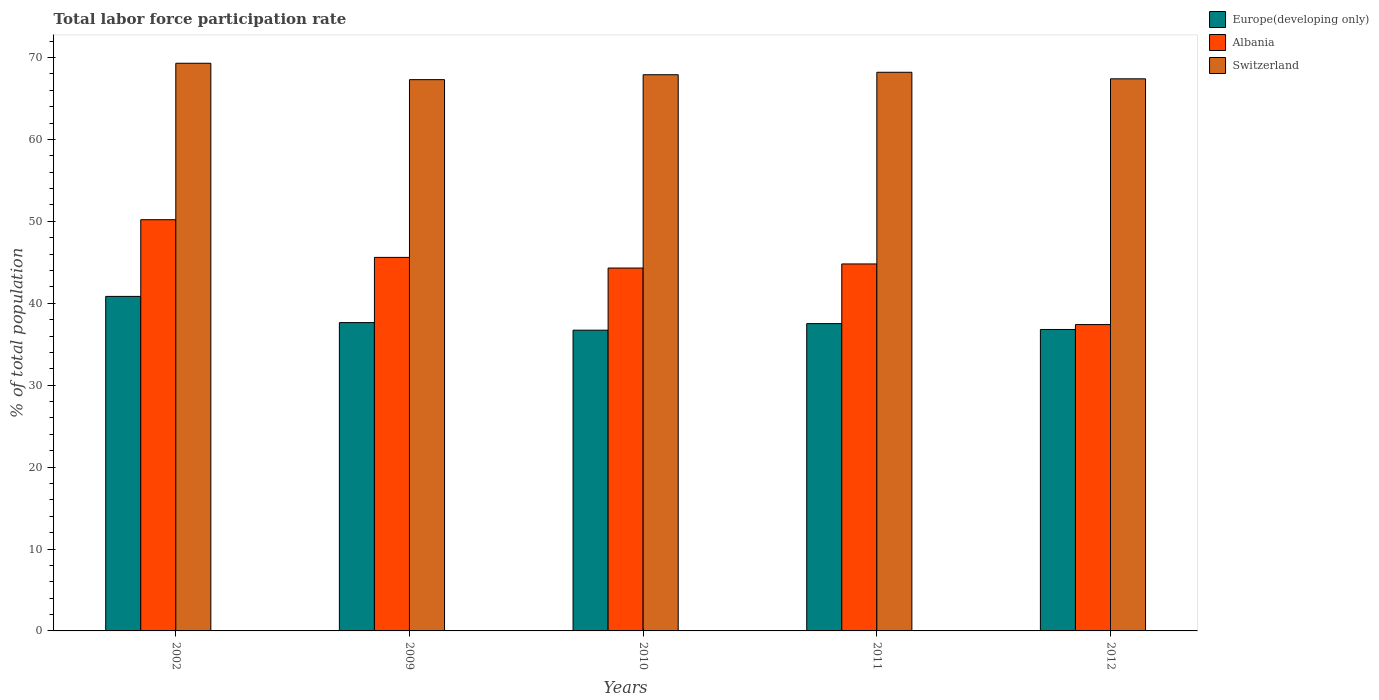Are the number of bars on each tick of the X-axis equal?
Make the answer very short. Yes. How many bars are there on the 4th tick from the left?
Your response must be concise. 3. How many bars are there on the 3rd tick from the right?
Your response must be concise. 3. In how many cases, is the number of bars for a given year not equal to the number of legend labels?
Ensure brevity in your answer.  0. What is the total labor force participation rate in Albania in 2012?
Make the answer very short. 37.4. Across all years, what is the maximum total labor force participation rate in Europe(developing only)?
Offer a terse response. 40.84. Across all years, what is the minimum total labor force participation rate in Albania?
Your response must be concise. 37.4. What is the total total labor force participation rate in Albania in the graph?
Offer a terse response. 222.3. What is the difference between the total labor force participation rate in Switzerland in 2002 and that in 2011?
Offer a very short reply. 1.1. What is the difference between the total labor force participation rate in Europe(developing only) in 2009 and the total labor force participation rate in Albania in 2012?
Keep it short and to the point. 0.24. What is the average total labor force participation rate in Albania per year?
Provide a succinct answer. 44.46. In the year 2010, what is the difference between the total labor force participation rate in Europe(developing only) and total labor force participation rate in Switzerland?
Provide a short and direct response. -31.19. What is the ratio of the total labor force participation rate in Europe(developing only) in 2002 to that in 2010?
Your answer should be compact. 1.11. What is the difference between the highest and the second highest total labor force participation rate in Switzerland?
Provide a succinct answer. 1.1. What is the difference between the highest and the lowest total labor force participation rate in Albania?
Offer a terse response. 12.8. In how many years, is the total labor force participation rate in Albania greater than the average total labor force participation rate in Albania taken over all years?
Give a very brief answer. 3. Is the sum of the total labor force participation rate in Switzerland in 2010 and 2012 greater than the maximum total labor force participation rate in Europe(developing only) across all years?
Offer a terse response. Yes. What does the 3rd bar from the left in 2009 represents?
Ensure brevity in your answer.  Switzerland. What does the 2nd bar from the right in 2009 represents?
Make the answer very short. Albania. Are all the bars in the graph horizontal?
Your response must be concise. No. How many years are there in the graph?
Your answer should be very brief. 5. What is the difference between two consecutive major ticks on the Y-axis?
Give a very brief answer. 10. Are the values on the major ticks of Y-axis written in scientific E-notation?
Provide a succinct answer. No. Does the graph contain any zero values?
Give a very brief answer. No. Where does the legend appear in the graph?
Offer a very short reply. Top right. How many legend labels are there?
Your answer should be compact. 3. What is the title of the graph?
Provide a short and direct response. Total labor force participation rate. Does "Korea (Republic)" appear as one of the legend labels in the graph?
Your response must be concise. No. What is the label or title of the Y-axis?
Offer a terse response. % of total population. What is the % of total population in Europe(developing only) in 2002?
Your answer should be very brief. 40.84. What is the % of total population of Albania in 2002?
Offer a terse response. 50.2. What is the % of total population in Switzerland in 2002?
Give a very brief answer. 69.3. What is the % of total population in Europe(developing only) in 2009?
Provide a short and direct response. 37.64. What is the % of total population of Albania in 2009?
Make the answer very short. 45.6. What is the % of total population in Switzerland in 2009?
Give a very brief answer. 67.3. What is the % of total population of Europe(developing only) in 2010?
Give a very brief answer. 36.71. What is the % of total population of Albania in 2010?
Make the answer very short. 44.3. What is the % of total population in Switzerland in 2010?
Offer a terse response. 67.9. What is the % of total population in Europe(developing only) in 2011?
Your answer should be very brief. 37.52. What is the % of total population of Albania in 2011?
Provide a succinct answer. 44.8. What is the % of total population of Switzerland in 2011?
Offer a terse response. 68.2. What is the % of total population of Europe(developing only) in 2012?
Give a very brief answer. 36.8. What is the % of total population in Albania in 2012?
Offer a very short reply. 37.4. What is the % of total population in Switzerland in 2012?
Offer a very short reply. 67.4. Across all years, what is the maximum % of total population of Europe(developing only)?
Provide a succinct answer. 40.84. Across all years, what is the maximum % of total population in Albania?
Your answer should be very brief. 50.2. Across all years, what is the maximum % of total population of Switzerland?
Your answer should be very brief. 69.3. Across all years, what is the minimum % of total population in Europe(developing only)?
Offer a terse response. 36.71. Across all years, what is the minimum % of total population in Albania?
Your answer should be compact. 37.4. Across all years, what is the minimum % of total population in Switzerland?
Provide a succinct answer. 67.3. What is the total % of total population in Europe(developing only) in the graph?
Your answer should be very brief. 189.51. What is the total % of total population in Albania in the graph?
Offer a terse response. 222.3. What is the total % of total population of Switzerland in the graph?
Offer a terse response. 340.1. What is the difference between the % of total population in Europe(developing only) in 2002 and that in 2009?
Keep it short and to the point. 3.2. What is the difference between the % of total population of Albania in 2002 and that in 2009?
Your answer should be compact. 4.6. What is the difference between the % of total population in Switzerland in 2002 and that in 2009?
Give a very brief answer. 2. What is the difference between the % of total population in Europe(developing only) in 2002 and that in 2010?
Keep it short and to the point. 4.12. What is the difference between the % of total population of Europe(developing only) in 2002 and that in 2011?
Make the answer very short. 3.32. What is the difference between the % of total population in Albania in 2002 and that in 2011?
Your answer should be compact. 5.4. What is the difference between the % of total population in Europe(developing only) in 2002 and that in 2012?
Your answer should be very brief. 4.04. What is the difference between the % of total population of Albania in 2002 and that in 2012?
Your answer should be compact. 12.8. What is the difference between the % of total population in Switzerland in 2002 and that in 2012?
Make the answer very short. 1.9. What is the difference between the % of total population of Europe(developing only) in 2009 and that in 2010?
Give a very brief answer. 0.92. What is the difference between the % of total population of Albania in 2009 and that in 2010?
Your answer should be compact. 1.3. What is the difference between the % of total population in Switzerland in 2009 and that in 2010?
Your answer should be compact. -0.6. What is the difference between the % of total population in Europe(developing only) in 2009 and that in 2011?
Your answer should be very brief. 0.12. What is the difference between the % of total population of Albania in 2009 and that in 2011?
Your response must be concise. 0.8. What is the difference between the % of total population in Europe(developing only) in 2009 and that in 2012?
Make the answer very short. 0.84. What is the difference between the % of total population in Albania in 2009 and that in 2012?
Your answer should be very brief. 8.2. What is the difference between the % of total population of Europe(developing only) in 2010 and that in 2011?
Your response must be concise. -0.8. What is the difference between the % of total population in Albania in 2010 and that in 2011?
Your response must be concise. -0.5. What is the difference between the % of total population of Switzerland in 2010 and that in 2011?
Ensure brevity in your answer.  -0.3. What is the difference between the % of total population of Europe(developing only) in 2010 and that in 2012?
Provide a succinct answer. -0.09. What is the difference between the % of total population of Switzerland in 2010 and that in 2012?
Give a very brief answer. 0.5. What is the difference between the % of total population in Europe(developing only) in 2011 and that in 2012?
Your response must be concise. 0.72. What is the difference between the % of total population in Switzerland in 2011 and that in 2012?
Your response must be concise. 0.8. What is the difference between the % of total population of Europe(developing only) in 2002 and the % of total population of Albania in 2009?
Your response must be concise. -4.76. What is the difference between the % of total population in Europe(developing only) in 2002 and the % of total population in Switzerland in 2009?
Keep it short and to the point. -26.46. What is the difference between the % of total population in Albania in 2002 and the % of total population in Switzerland in 2009?
Your response must be concise. -17.1. What is the difference between the % of total population of Europe(developing only) in 2002 and the % of total population of Albania in 2010?
Ensure brevity in your answer.  -3.46. What is the difference between the % of total population of Europe(developing only) in 2002 and the % of total population of Switzerland in 2010?
Give a very brief answer. -27.06. What is the difference between the % of total population in Albania in 2002 and the % of total population in Switzerland in 2010?
Keep it short and to the point. -17.7. What is the difference between the % of total population in Europe(developing only) in 2002 and the % of total population in Albania in 2011?
Offer a very short reply. -3.96. What is the difference between the % of total population in Europe(developing only) in 2002 and the % of total population in Switzerland in 2011?
Make the answer very short. -27.36. What is the difference between the % of total population of Albania in 2002 and the % of total population of Switzerland in 2011?
Offer a very short reply. -18. What is the difference between the % of total population of Europe(developing only) in 2002 and the % of total population of Albania in 2012?
Ensure brevity in your answer.  3.44. What is the difference between the % of total population in Europe(developing only) in 2002 and the % of total population in Switzerland in 2012?
Offer a terse response. -26.56. What is the difference between the % of total population in Albania in 2002 and the % of total population in Switzerland in 2012?
Provide a short and direct response. -17.2. What is the difference between the % of total population of Europe(developing only) in 2009 and the % of total population of Albania in 2010?
Your answer should be very brief. -6.66. What is the difference between the % of total population of Europe(developing only) in 2009 and the % of total population of Switzerland in 2010?
Keep it short and to the point. -30.26. What is the difference between the % of total population in Albania in 2009 and the % of total population in Switzerland in 2010?
Offer a terse response. -22.3. What is the difference between the % of total population of Europe(developing only) in 2009 and the % of total population of Albania in 2011?
Your response must be concise. -7.16. What is the difference between the % of total population of Europe(developing only) in 2009 and the % of total population of Switzerland in 2011?
Your response must be concise. -30.56. What is the difference between the % of total population in Albania in 2009 and the % of total population in Switzerland in 2011?
Your answer should be compact. -22.6. What is the difference between the % of total population of Europe(developing only) in 2009 and the % of total population of Albania in 2012?
Offer a very short reply. 0.24. What is the difference between the % of total population of Europe(developing only) in 2009 and the % of total population of Switzerland in 2012?
Your answer should be very brief. -29.76. What is the difference between the % of total population of Albania in 2009 and the % of total population of Switzerland in 2012?
Provide a succinct answer. -21.8. What is the difference between the % of total population in Europe(developing only) in 2010 and the % of total population in Albania in 2011?
Keep it short and to the point. -8.09. What is the difference between the % of total population in Europe(developing only) in 2010 and the % of total population in Switzerland in 2011?
Your response must be concise. -31.49. What is the difference between the % of total population of Albania in 2010 and the % of total population of Switzerland in 2011?
Provide a short and direct response. -23.9. What is the difference between the % of total population in Europe(developing only) in 2010 and the % of total population in Albania in 2012?
Offer a terse response. -0.69. What is the difference between the % of total population in Europe(developing only) in 2010 and the % of total population in Switzerland in 2012?
Offer a very short reply. -30.69. What is the difference between the % of total population of Albania in 2010 and the % of total population of Switzerland in 2012?
Offer a terse response. -23.1. What is the difference between the % of total population in Europe(developing only) in 2011 and the % of total population in Albania in 2012?
Keep it short and to the point. 0.12. What is the difference between the % of total population in Europe(developing only) in 2011 and the % of total population in Switzerland in 2012?
Keep it short and to the point. -29.88. What is the difference between the % of total population of Albania in 2011 and the % of total population of Switzerland in 2012?
Your response must be concise. -22.6. What is the average % of total population in Europe(developing only) per year?
Keep it short and to the point. 37.9. What is the average % of total population of Albania per year?
Offer a terse response. 44.46. What is the average % of total population of Switzerland per year?
Offer a very short reply. 68.02. In the year 2002, what is the difference between the % of total population of Europe(developing only) and % of total population of Albania?
Give a very brief answer. -9.36. In the year 2002, what is the difference between the % of total population of Europe(developing only) and % of total population of Switzerland?
Give a very brief answer. -28.46. In the year 2002, what is the difference between the % of total population in Albania and % of total population in Switzerland?
Your response must be concise. -19.1. In the year 2009, what is the difference between the % of total population in Europe(developing only) and % of total population in Albania?
Offer a terse response. -7.96. In the year 2009, what is the difference between the % of total population in Europe(developing only) and % of total population in Switzerland?
Your answer should be very brief. -29.66. In the year 2009, what is the difference between the % of total population in Albania and % of total population in Switzerland?
Keep it short and to the point. -21.7. In the year 2010, what is the difference between the % of total population of Europe(developing only) and % of total population of Albania?
Provide a succinct answer. -7.59. In the year 2010, what is the difference between the % of total population of Europe(developing only) and % of total population of Switzerland?
Ensure brevity in your answer.  -31.19. In the year 2010, what is the difference between the % of total population in Albania and % of total population in Switzerland?
Ensure brevity in your answer.  -23.6. In the year 2011, what is the difference between the % of total population in Europe(developing only) and % of total population in Albania?
Offer a terse response. -7.28. In the year 2011, what is the difference between the % of total population of Europe(developing only) and % of total population of Switzerland?
Provide a succinct answer. -30.68. In the year 2011, what is the difference between the % of total population in Albania and % of total population in Switzerland?
Offer a terse response. -23.4. In the year 2012, what is the difference between the % of total population of Europe(developing only) and % of total population of Albania?
Your answer should be compact. -0.6. In the year 2012, what is the difference between the % of total population in Europe(developing only) and % of total population in Switzerland?
Make the answer very short. -30.6. What is the ratio of the % of total population of Europe(developing only) in 2002 to that in 2009?
Give a very brief answer. 1.08. What is the ratio of the % of total population of Albania in 2002 to that in 2009?
Offer a very short reply. 1.1. What is the ratio of the % of total population in Switzerland in 2002 to that in 2009?
Give a very brief answer. 1.03. What is the ratio of the % of total population in Europe(developing only) in 2002 to that in 2010?
Make the answer very short. 1.11. What is the ratio of the % of total population of Albania in 2002 to that in 2010?
Provide a succinct answer. 1.13. What is the ratio of the % of total population of Switzerland in 2002 to that in 2010?
Make the answer very short. 1.02. What is the ratio of the % of total population of Europe(developing only) in 2002 to that in 2011?
Give a very brief answer. 1.09. What is the ratio of the % of total population of Albania in 2002 to that in 2011?
Give a very brief answer. 1.12. What is the ratio of the % of total population of Switzerland in 2002 to that in 2011?
Offer a very short reply. 1.02. What is the ratio of the % of total population in Europe(developing only) in 2002 to that in 2012?
Give a very brief answer. 1.11. What is the ratio of the % of total population of Albania in 2002 to that in 2012?
Provide a short and direct response. 1.34. What is the ratio of the % of total population in Switzerland in 2002 to that in 2012?
Give a very brief answer. 1.03. What is the ratio of the % of total population in Europe(developing only) in 2009 to that in 2010?
Provide a succinct answer. 1.03. What is the ratio of the % of total population of Albania in 2009 to that in 2010?
Make the answer very short. 1.03. What is the ratio of the % of total population of Switzerland in 2009 to that in 2010?
Offer a terse response. 0.99. What is the ratio of the % of total population of Europe(developing only) in 2009 to that in 2011?
Provide a succinct answer. 1. What is the ratio of the % of total population of Albania in 2009 to that in 2011?
Offer a terse response. 1.02. What is the ratio of the % of total population of Switzerland in 2009 to that in 2011?
Give a very brief answer. 0.99. What is the ratio of the % of total population in Europe(developing only) in 2009 to that in 2012?
Keep it short and to the point. 1.02. What is the ratio of the % of total population of Albania in 2009 to that in 2012?
Your answer should be compact. 1.22. What is the ratio of the % of total population in Switzerland in 2009 to that in 2012?
Offer a terse response. 1. What is the ratio of the % of total population of Europe(developing only) in 2010 to that in 2011?
Your response must be concise. 0.98. What is the ratio of the % of total population of Albania in 2010 to that in 2012?
Your answer should be compact. 1.18. What is the ratio of the % of total population of Switzerland in 2010 to that in 2012?
Your response must be concise. 1.01. What is the ratio of the % of total population in Europe(developing only) in 2011 to that in 2012?
Make the answer very short. 1.02. What is the ratio of the % of total population of Albania in 2011 to that in 2012?
Keep it short and to the point. 1.2. What is the ratio of the % of total population in Switzerland in 2011 to that in 2012?
Your answer should be compact. 1.01. What is the difference between the highest and the second highest % of total population of Europe(developing only)?
Make the answer very short. 3.2. What is the difference between the highest and the second highest % of total population of Albania?
Your answer should be very brief. 4.6. What is the difference between the highest and the lowest % of total population of Europe(developing only)?
Your response must be concise. 4.12. What is the difference between the highest and the lowest % of total population of Albania?
Give a very brief answer. 12.8. 